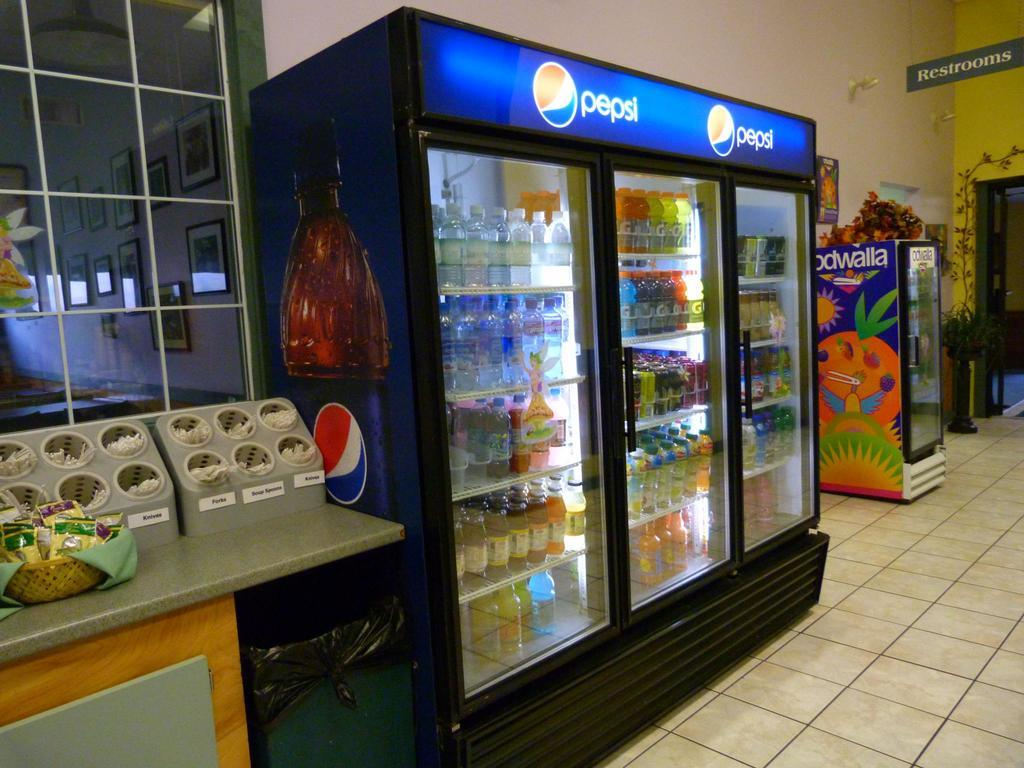Provide a one-sentence caption for the provided image. Various beverages are displayed in a cooler with the Pepsi brand on top. 